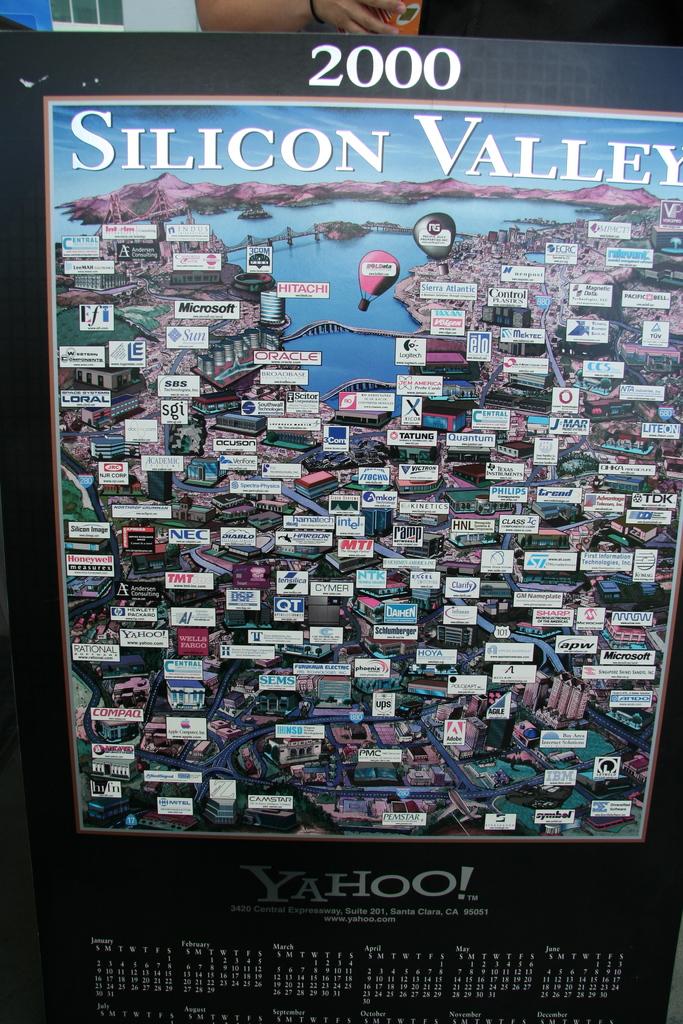What year is this calendar?
Your answer should be compact. 2000. Is yahoo a sponsor?
Offer a terse response. Yes. 